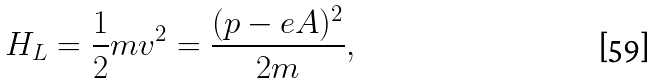Convert formula to latex. <formula><loc_0><loc_0><loc_500><loc_500>H _ { L } = \frac { 1 } { 2 } m { v } ^ { 2 } = \frac { ( { p } - e { A } ) ^ { 2 } } { 2 m } ,</formula> 